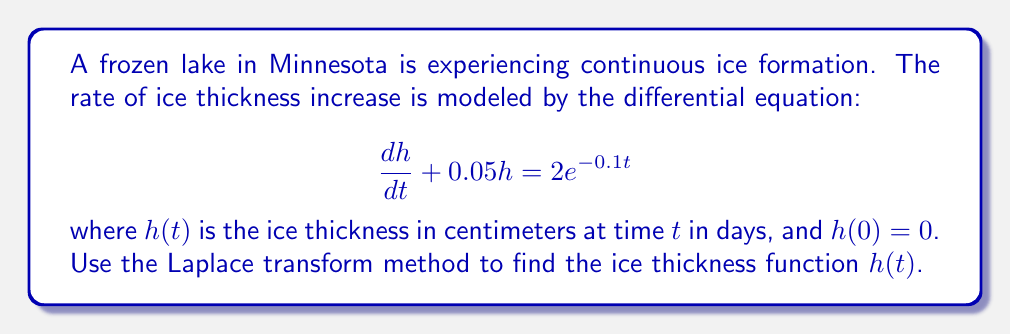Can you solve this math problem? Let's solve this problem step by step using the Laplace transform method:

1) First, we take the Laplace transform of both sides of the equation:

   $\mathcal{L}\{\frac{dh}{dt} + 0.05h\} = \mathcal{L}\{2e^{-0.1t}\}$

2) Using the linearity property and the Laplace transform of the derivative:

   $s\mathcal{L}\{h\} - h(0) + 0.05\mathcal{L}\{h\} = \frac{2}{s+0.1}$

3) Since $h(0) = 0$, we can simplify:

   $s\mathcal{L}\{h\} + 0.05\mathcal{L}\{h\} = \frac{2}{s+0.1}$

4) Factor out $\mathcal{L}\{h\}$:

   $\mathcal{L}\{h\}(s + 0.05) = \frac{2}{s+0.1}$

5) Solve for $\mathcal{L}\{h\}$:

   $\mathcal{L}\{h\} = \frac{2}{(s+0.05)(s+0.1)}$

6) Use partial fraction decomposition:

   $\frac{2}{(s+0.05)(s+0.1)} = \frac{A}{s+0.05} + \frac{B}{s+0.1}$

   where $A = \frac{2}{0.05-0.1} = -40$ and $B = \frac{2}{0.1-0.05} = 40$

7) So, we have:

   $\mathcal{L}\{h\} = \frac{-40}{s+0.05} + \frac{40}{s+0.1}$

8) Now, we can take the inverse Laplace transform:

   $h(t) = -40e^{-0.05t} + 40e^{-0.1t}$

This is the solution to the differential equation, representing the ice thickness as a function of time.
Answer: $h(t) = -40e^{-0.05t} + 40e^{-0.1t}$ cm 